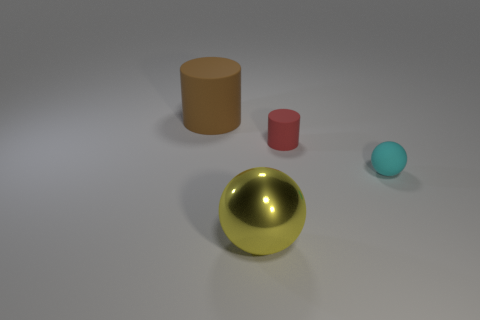Add 4 red rubber blocks. How many objects exist? 8 Subtract all large brown shiny cylinders. Subtract all cyan rubber things. How many objects are left? 3 Add 4 red rubber things. How many red rubber things are left? 5 Add 1 big yellow metallic cylinders. How many big yellow metallic cylinders exist? 1 Subtract 0 yellow cylinders. How many objects are left? 4 